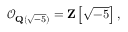Convert formula to latex. <formula><loc_0><loc_0><loc_500><loc_500>{ \mathcal { O } } _ { Q ( { \sqrt { - 5 } } ) } = Z \left [ { \sqrt { - 5 } } \right ] ,</formula> 